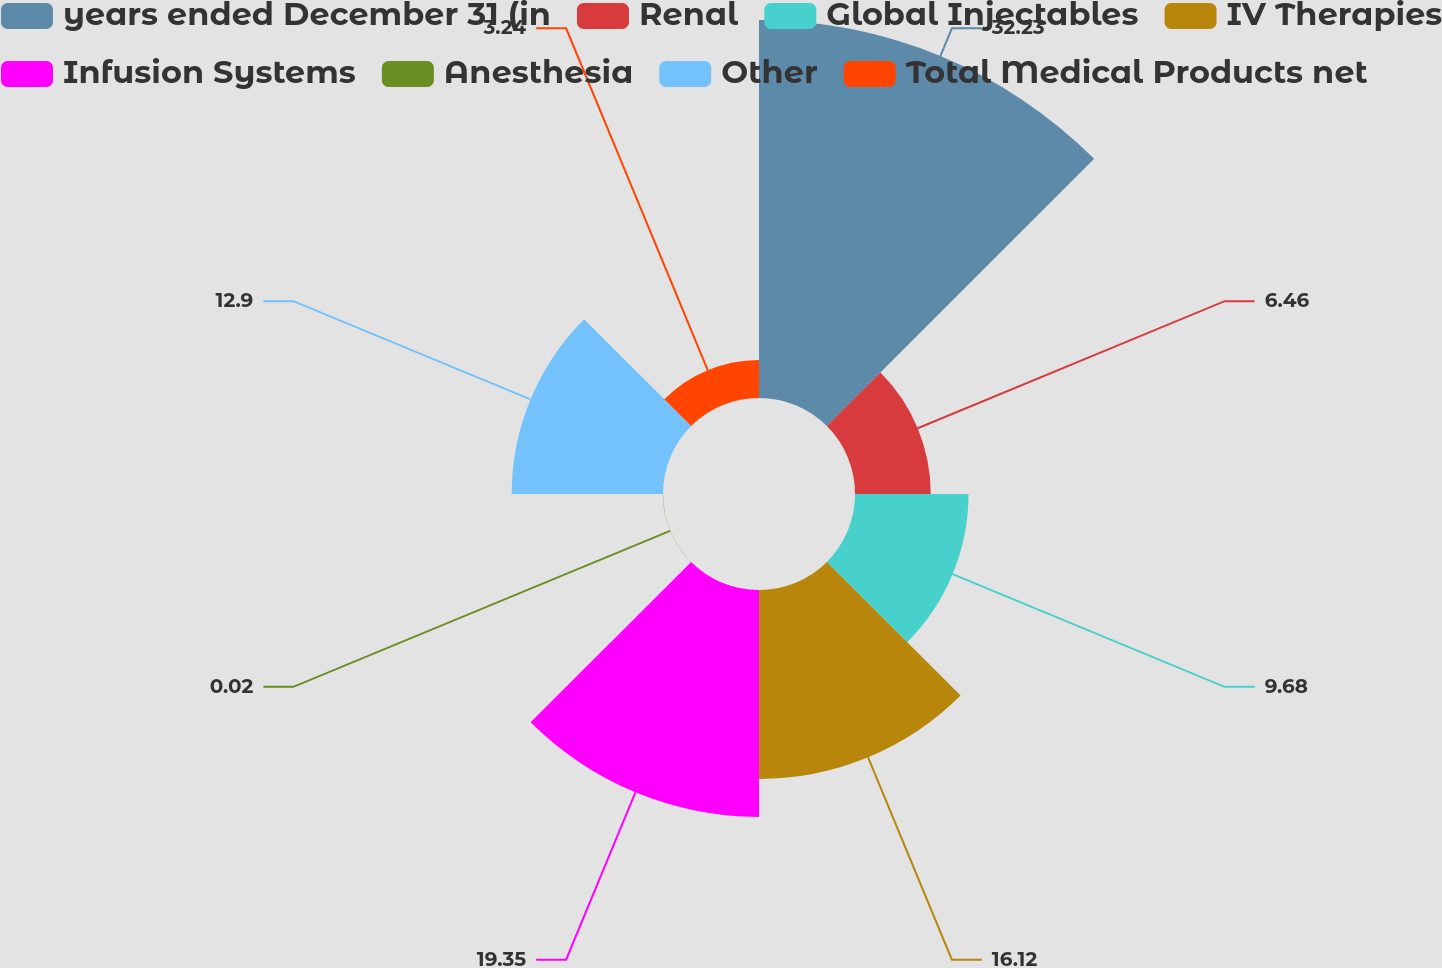Convert chart to OTSL. <chart><loc_0><loc_0><loc_500><loc_500><pie_chart><fcel>years ended December 31 (in<fcel>Renal<fcel>Global Injectables<fcel>IV Therapies<fcel>Infusion Systems<fcel>Anesthesia<fcel>Other<fcel>Total Medical Products net<nl><fcel>32.23%<fcel>6.46%<fcel>9.68%<fcel>16.12%<fcel>19.35%<fcel>0.02%<fcel>12.9%<fcel>3.24%<nl></chart> 